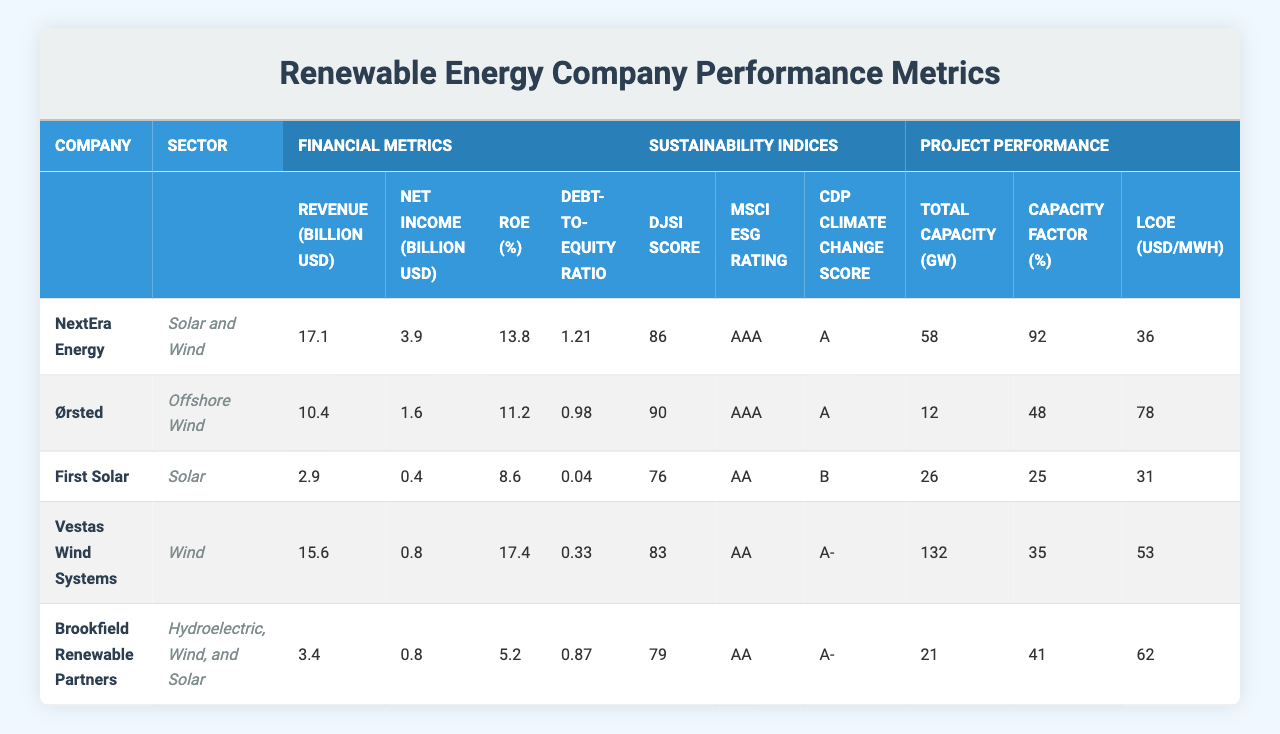What is the revenue of NextEra Energy? The table lists the financial metrics for NextEra Energy, showing that its revenue is 17.1 billion USD.
Answer: 17.1 billion USD Which company has the highest ROE? The table indicates that Vestas Wind Systems has the highest ROE at 17.4%.
Answer: Vestas Wind Systems What is the Debt-to-Equity Ratio of First Solar? The table shows that First Solar's Debt-to-Equity Ratio is 0.04.
Answer: 0.04 Which company scored 90 on the Dow Jones Sustainability Index? Ørsted is listed with a Dow Jones Sustainability Index Score of 90.
Answer: Ørsted What is the average LCOE of the companies listed? To calculate the average LCOE, add the LCOE values (36 + 78 + 31 + 53 + 62 = 260) and divide by the number of companies (5), resulting in an average of 52 USD/MWh.
Answer: 52 USD/MWh Does Brookfield Renewable Partners have a higher Capacity Factor than First Solar? The Capacity Factor for Brookfield Renewable Partners is 41%, while First Solar has a Capacity Factor of 25%. Therefore, Brookfield Renewable Partners has a higher Capacity Factor.
Answer: Yes Which company has the lowest Debt-to-Equity Ratio? In the table, First Solar is noted to have the lowest Debt-to-Equity Ratio of 0.04.
Answer: First Solar What is the total revenue generated by all companies listed? To find the total revenue, sum the revenues of all companies (17.1 + 10.4 + 2.9 + 15.6 + 3.4 = 49.4 billion USD).
Answer: 49.4 billion USD Which company has the highest sustainability index score? Ørsted has the highest Dow Jones Sustainability Index Score at 90, compared to the others listed.
Answer: Ørsted If you add the net incomes of all companies, what is the total? Adding the net incomes (3.9 + 1.6 + 0.4 + 0.8 + 0.8 = 7.5 billion USD) gives the total net income for all companies.
Answer: 7.5 billion USD Is NextEra Energy's Capacity Factor greater than Vestas Wind Systems'? NextEra Energy has a Capacity Factor of 92%, while Vestas Wind Systems has 35%. Therefore, NextEra Energy's Capacity Factor is greater.
Answer: Yes 